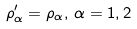<formula> <loc_0><loc_0><loc_500><loc_500>\rho ^ { \prime } _ { \alpha } = \rho _ { \alpha } , \, \alpha = 1 , 2 \,</formula> 